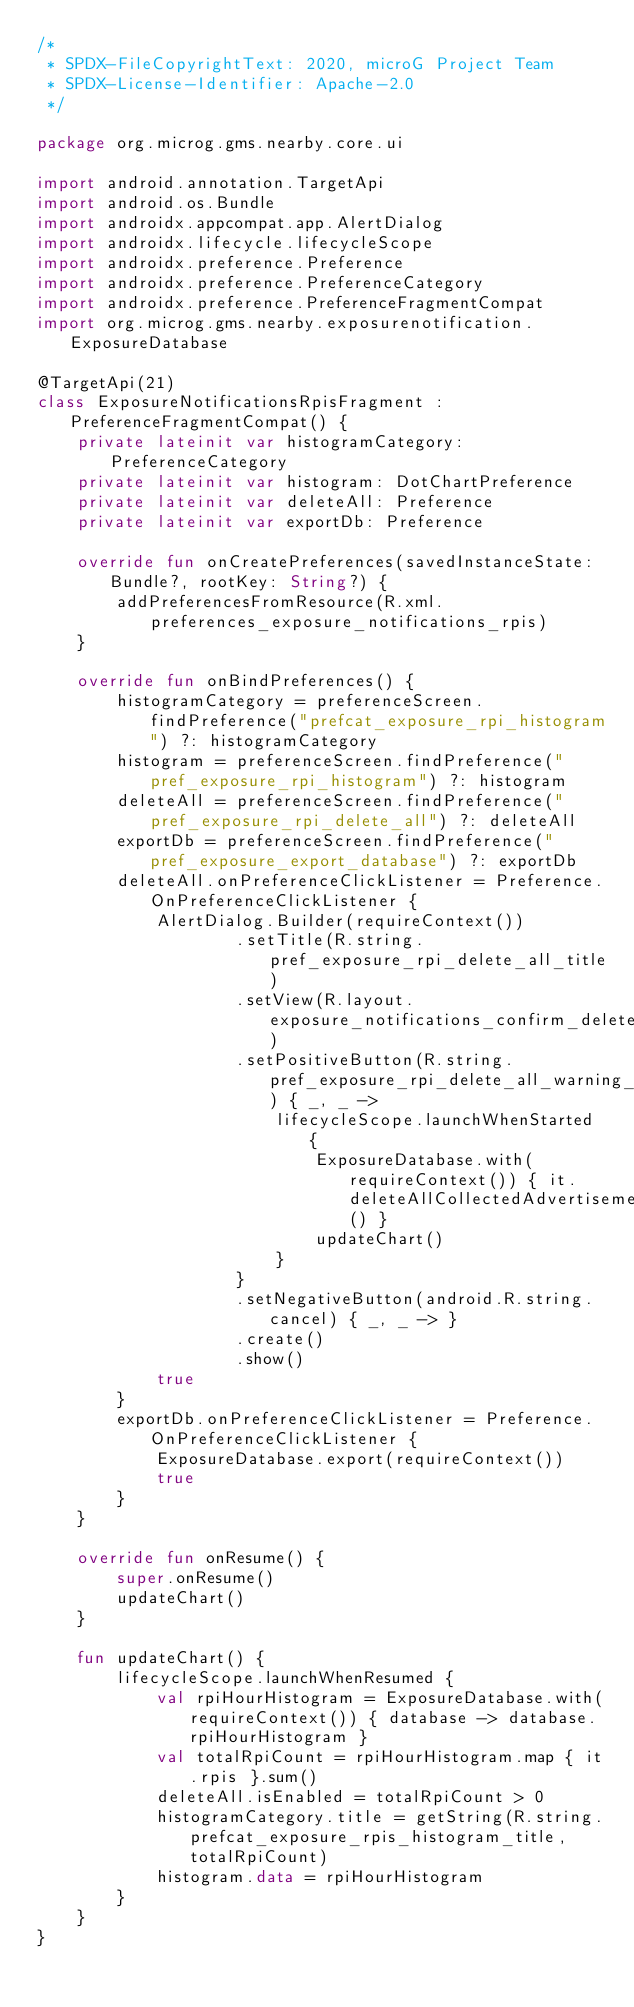<code> <loc_0><loc_0><loc_500><loc_500><_Kotlin_>/*
 * SPDX-FileCopyrightText: 2020, microG Project Team
 * SPDX-License-Identifier: Apache-2.0
 */

package org.microg.gms.nearby.core.ui

import android.annotation.TargetApi
import android.os.Bundle
import androidx.appcompat.app.AlertDialog
import androidx.lifecycle.lifecycleScope
import androidx.preference.Preference
import androidx.preference.PreferenceCategory
import androidx.preference.PreferenceFragmentCompat
import org.microg.gms.nearby.exposurenotification.ExposureDatabase

@TargetApi(21)
class ExposureNotificationsRpisFragment : PreferenceFragmentCompat() {
    private lateinit var histogramCategory: PreferenceCategory
    private lateinit var histogram: DotChartPreference
    private lateinit var deleteAll: Preference
    private lateinit var exportDb: Preference

    override fun onCreatePreferences(savedInstanceState: Bundle?, rootKey: String?) {
        addPreferencesFromResource(R.xml.preferences_exposure_notifications_rpis)
    }

    override fun onBindPreferences() {
        histogramCategory = preferenceScreen.findPreference("prefcat_exposure_rpi_histogram") ?: histogramCategory
        histogram = preferenceScreen.findPreference("pref_exposure_rpi_histogram") ?: histogram
        deleteAll = preferenceScreen.findPreference("pref_exposure_rpi_delete_all") ?: deleteAll
        exportDb = preferenceScreen.findPreference("pref_exposure_export_database") ?: exportDb
        deleteAll.onPreferenceClickListener = Preference.OnPreferenceClickListener {
            AlertDialog.Builder(requireContext())
                    .setTitle(R.string.pref_exposure_rpi_delete_all_title)
                    .setView(R.layout.exposure_notifications_confirm_delete)
                    .setPositiveButton(R.string.pref_exposure_rpi_delete_all_warning_confirm_button) { _, _ ->
                        lifecycleScope.launchWhenStarted {
                            ExposureDatabase.with(requireContext()) { it.deleteAllCollectedAdvertisements() }
                            updateChart()
                        }
                    }
                    .setNegativeButton(android.R.string.cancel) { _, _ -> }
                    .create()
                    .show()
            true
        }
        exportDb.onPreferenceClickListener = Preference.OnPreferenceClickListener {
            ExposureDatabase.export(requireContext())
            true
        }
    }

    override fun onResume() {
        super.onResume()
        updateChart()
    }

    fun updateChart() {
        lifecycleScope.launchWhenResumed {
            val rpiHourHistogram = ExposureDatabase.with(requireContext()) { database -> database.rpiHourHistogram }
            val totalRpiCount = rpiHourHistogram.map { it.rpis }.sum()
            deleteAll.isEnabled = totalRpiCount > 0
            histogramCategory.title = getString(R.string.prefcat_exposure_rpis_histogram_title, totalRpiCount)
            histogram.data = rpiHourHistogram
        }
    }
}
</code> 